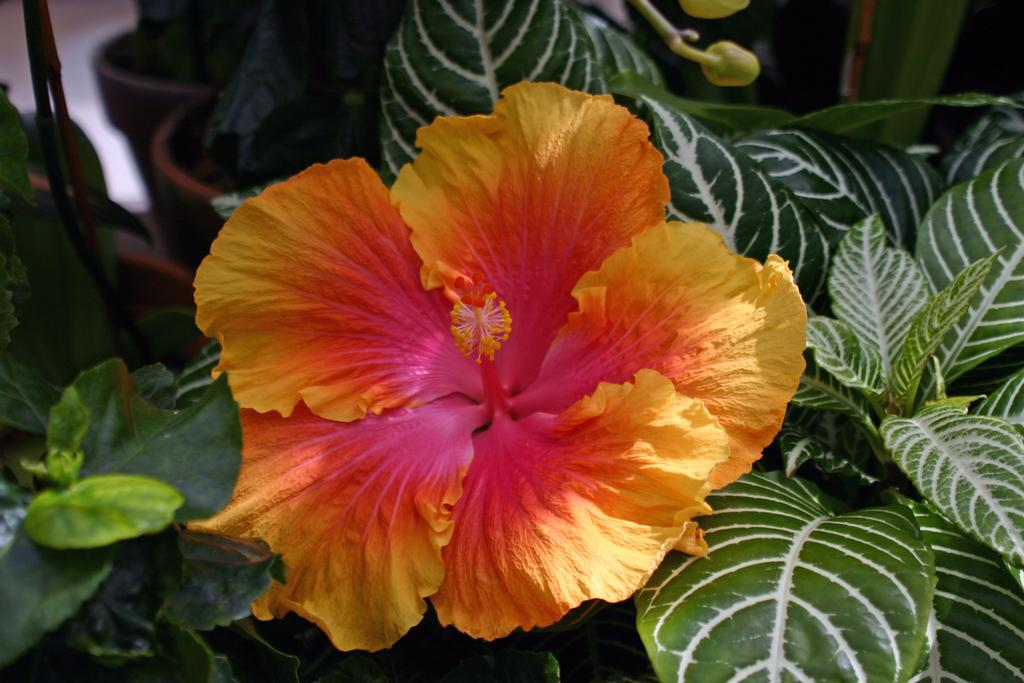What type of living organisms can be seen in the image? Plants and flowers are visible in the image. What stage of growth are some of the plants in? There are buds in the image, indicating that some plants are in the early stages of growth. How are the plants contained in the image? The plants are in pots. What part of the image shows the floor? The top left corner of the image shows the floor. What type of action is the sack performing in the image? There is no sack present in the image, so it cannot perform any actions. 